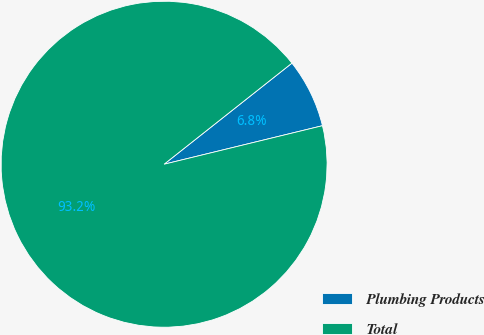<chart> <loc_0><loc_0><loc_500><loc_500><pie_chart><fcel>Plumbing Products<fcel>Total<nl><fcel>6.85%<fcel>93.15%<nl></chart> 